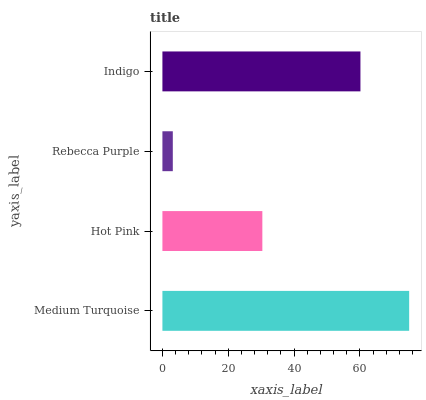Is Rebecca Purple the minimum?
Answer yes or no. Yes. Is Medium Turquoise the maximum?
Answer yes or no. Yes. Is Hot Pink the minimum?
Answer yes or no. No. Is Hot Pink the maximum?
Answer yes or no. No. Is Medium Turquoise greater than Hot Pink?
Answer yes or no. Yes. Is Hot Pink less than Medium Turquoise?
Answer yes or no. Yes. Is Hot Pink greater than Medium Turquoise?
Answer yes or no. No. Is Medium Turquoise less than Hot Pink?
Answer yes or no. No. Is Indigo the high median?
Answer yes or no. Yes. Is Hot Pink the low median?
Answer yes or no. Yes. Is Medium Turquoise the high median?
Answer yes or no. No. Is Indigo the low median?
Answer yes or no. No. 